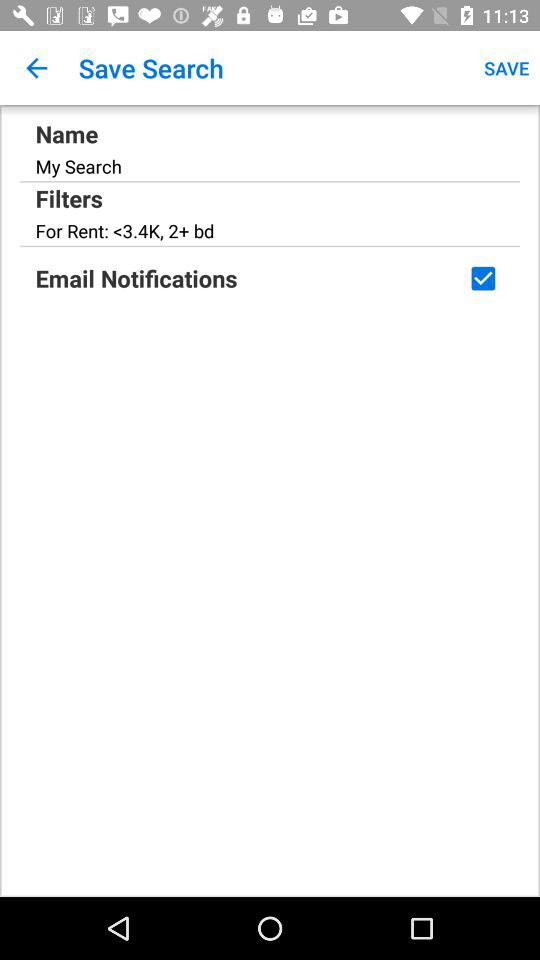What are the filters? The filters are "<3.4K" and "2+ bd". 